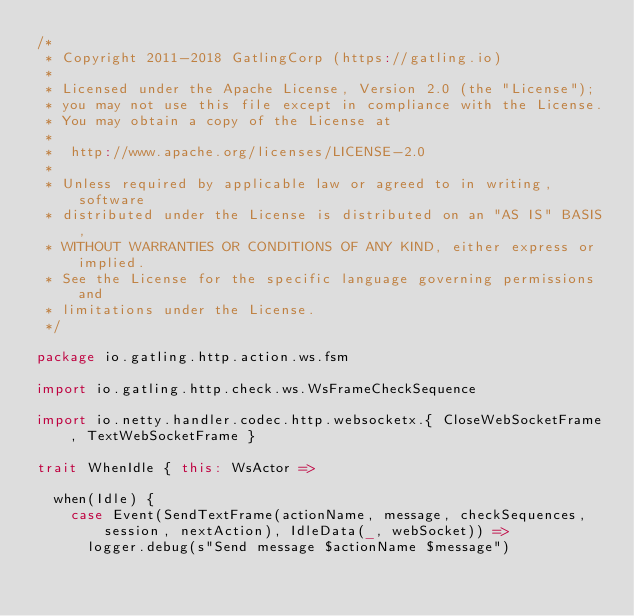<code> <loc_0><loc_0><loc_500><loc_500><_Scala_>/*
 * Copyright 2011-2018 GatlingCorp (https://gatling.io)
 *
 * Licensed under the Apache License, Version 2.0 (the "License");
 * you may not use this file except in compliance with the License.
 * You may obtain a copy of the License at
 *
 *  http://www.apache.org/licenses/LICENSE-2.0
 *
 * Unless required by applicable law or agreed to in writing, software
 * distributed under the License is distributed on an "AS IS" BASIS,
 * WITHOUT WARRANTIES OR CONDITIONS OF ANY KIND, either express or implied.
 * See the License for the specific language governing permissions and
 * limitations under the License.
 */

package io.gatling.http.action.ws.fsm

import io.gatling.http.check.ws.WsFrameCheckSequence

import io.netty.handler.codec.http.websocketx.{ CloseWebSocketFrame, TextWebSocketFrame }

trait WhenIdle { this: WsActor =>

  when(Idle) {
    case Event(SendTextFrame(actionName, message, checkSequences, session, nextAction), IdleData(_, webSocket)) =>
      logger.debug(s"Send message $actionName $message")</code> 